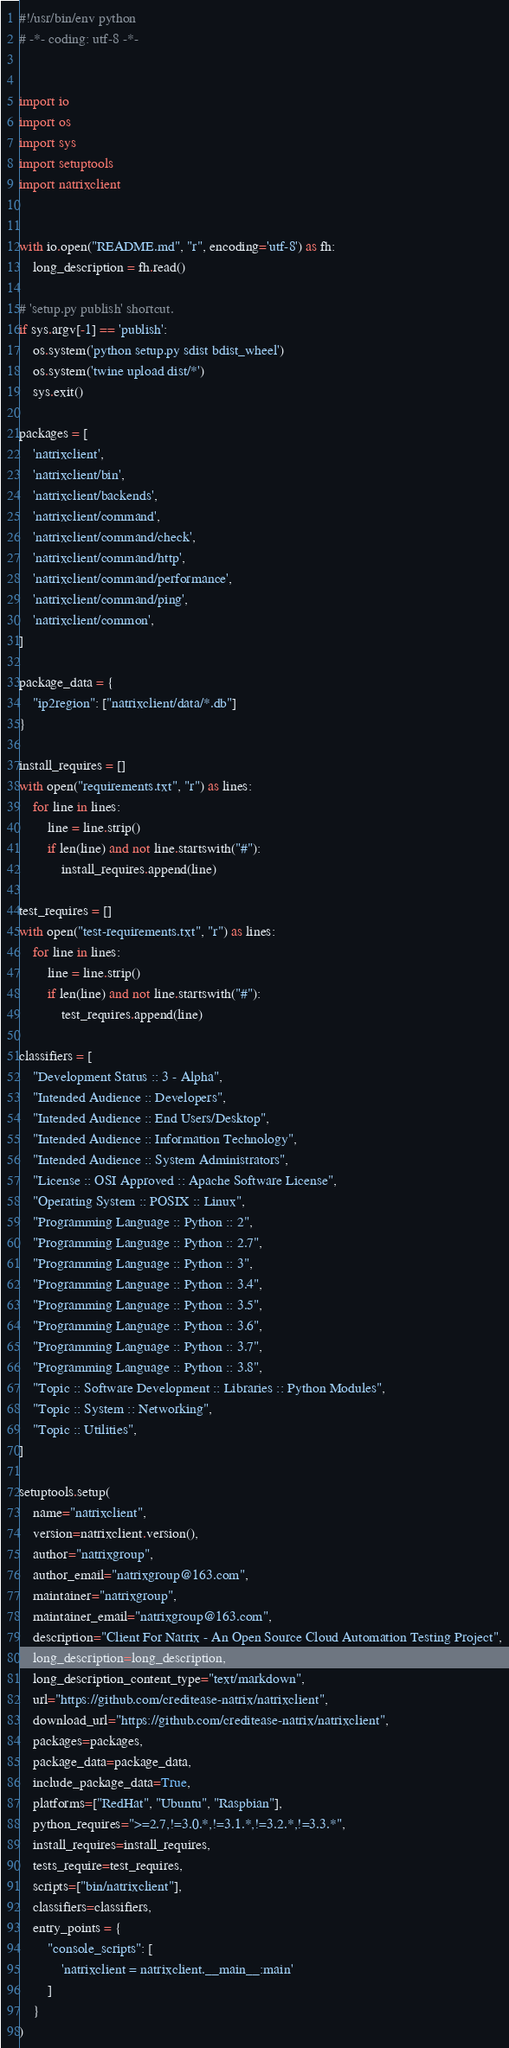Convert code to text. <code><loc_0><loc_0><loc_500><loc_500><_Python_>#!/usr/bin/env python
# -*- coding: utf-8 -*-


import io
import os
import sys
import setuptools
import natrixclient


with io.open("README.md", "r", encoding='utf-8') as fh:
    long_description = fh.read()

# 'setup.py publish' shortcut.
if sys.argv[-1] == 'publish':
    os.system('python setup.py sdist bdist_wheel')
    os.system('twine upload dist/*')
    sys.exit()

packages = [
    'natrixclient',
    'natrixclient/bin',
    'natrixclient/backends',
    'natrixclient/command',
    'natrixclient/command/check',
    'natrixclient/command/http',
    'natrixclient/command/performance',
    'natrixclient/command/ping',
    'natrixclient/common',
]

package_data = {
    "ip2region": ["natrixclient/data/*.db"]
}

install_requires = []
with open("requirements.txt", "r") as lines:
    for line in lines:
        line = line.strip()
        if len(line) and not line.startswith("#"):
            install_requires.append(line)

test_requires = []
with open("test-requirements.txt", "r") as lines:
    for line in lines:
        line = line.strip()
        if len(line) and not line.startswith("#"):
            test_requires.append(line)

classifiers = [
    "Development Status :: 3 - Alpha",
    "Intended Audience :: Developers",
    "Intended Audience :: End Users/Desktop",
    "Intended Audience :: Information Technology",
    "Intended Audience :: System Administrators",
    "License :: OSI Approved :: Apache Software License",
    "Operating System :: POSIX :: Linux",
    "Programming Language :: Python :: 2",
    "Programming Language :: Python :: 2.7",
    "Programming Language :: Python :: 3",
    "Programming Language :: Python :: 3.4",
    "Programming Language :: Python :: 3.5",
    "Programming Language :: Python :: 3.6",
    "Programming Language :: Python :: 3.7",
    "Programming Language :: Python :: 3.8",
    "Topic :: Software Development :: Libraries :: Python Modules",
    "Topic :: System :: Networking",
    "Topic :: Utilities",
]

setuptools.setup(
    name="natrixclient",
    version=natrixclient.version(),
    author="natrixgroup",
    author_email="natrixgroup@163.com",
    maintainer="natrixgroup",
    maintainer_email="natrixgroup@163.com",
    description="Client For Natrix - An Open Source Cloud Automation Testing Project",
    long_description=long_description,
    long_description_content_type="text/markdown",
    url="https://github.com/creditease-natrix/natrixclient",
    download_url="https://github.com/creditease-natrix/natrixclient",
    packages=packages,
    package_data=package_data,
    include_package_data=True,
    platforms=["RedHat", "Ubuntu", "Raspbian"],
    python_requires=">=2.7,!=3.0.*,!=3.1.*,!=3.2.*,!=3.3.*",
    install_requires=install_requires,
    tests_require=test_requires,
    scripts=["bin/natrixclient"],
    classifiers=classifiers,
    entry_points = {
        "console_scripts": [
            'natrixclient = natrixclient.__main__:main'
        ]
    }
)
</code> 